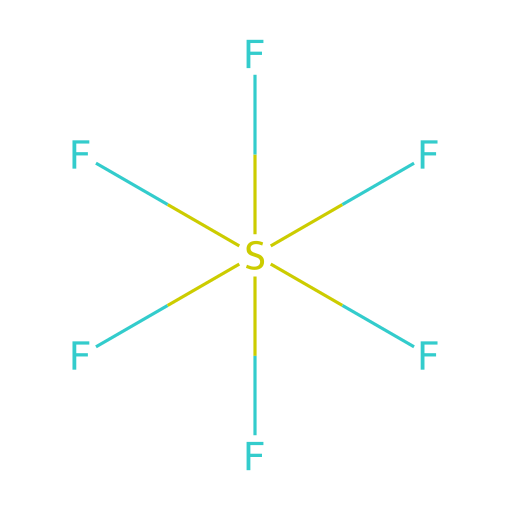What is the total number of fluorine atoms in sulfur hexafluoride? The chemical structure indicates six fluorine atoms are attached to the central sulfur atom, represented by the six 'F' in the SMILES notation.
Answer: six What is the central atom in this compound? In the given SMILES representation, sulfur is the central atom to which the fluorine atoms are bonded, indicated by the 'S' in the notation.
Answer: sulfur What type of bonding is present in sulfur hexafluoride? This compound features covalent bonding, as sulfur shares electrons with the fluorine atoms to achieve stability and satisfy the octet rule.
Answer: covalent How many single bonds are present in sulfur hexafluoride? Each fluorine atom forms a single bond with the sulfur atom, and since there are six fluorine atoms, there are six single bonds in total.
Answer: six Is sulfur hexafluoride a hypervalent compound? Yes, sulfur hexafluoride is categorized as a hypervalent compound because sulfur can accommodate more than eight electrons in its valence shell, due to its d-orbitals, allowing for six bonds.
Answer: yes What makes sulfur hexafluoride suitable for waterproofing in hunting clothing? The non-polar nature of sulfur hexafluoride, along with its chemical stability and inability to react with water, makes it effective as a waterproofing agent in such applications.
Answer: non-polar 